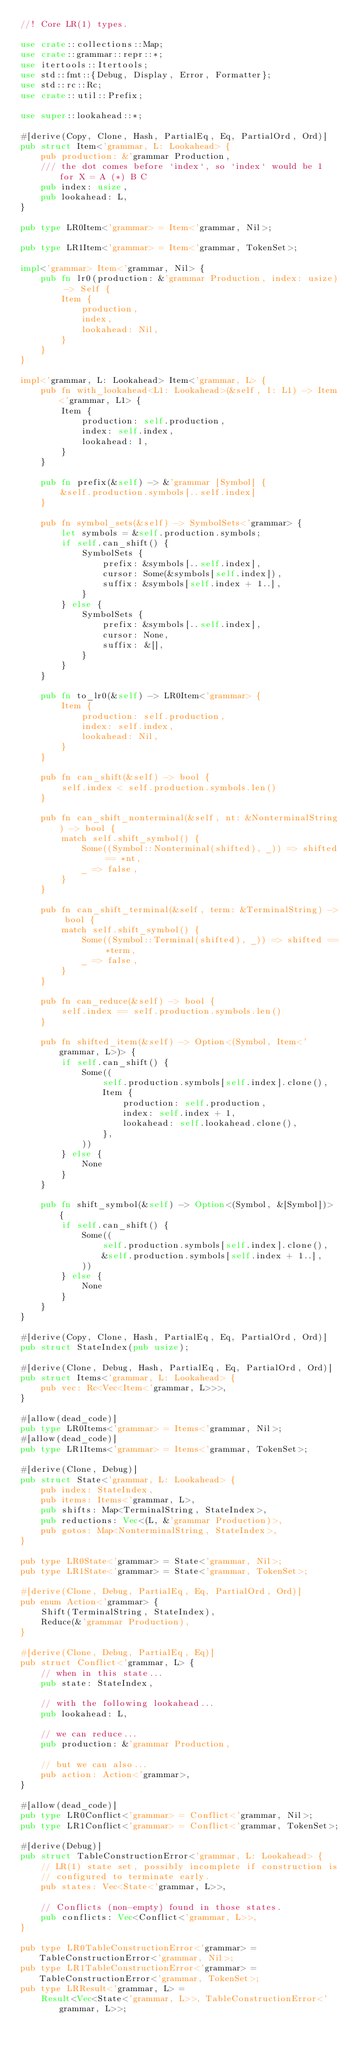<code> <loc_0><loc_0><loc_500><loc_500><_Rust_>//! Core LR(1) types.

use crate::collections::Map;
use crate::grammar::repr::*;
use itertools::Itertools;
use std::fmt::{Debug, Display, Error, Formatter};
use std::rc::Rc;
use crate::util::Prefix;

use super::lookahead::*;

#[derive(Copy, Clone, Hash, PartialEq, Eq, PartialOrd, Ord)]
pub struct Item<'grammar, L: Lookahead> {
    pub production: &'grammar Production,
    /// the dot comes before `index`, so `index` would be 1 for X = A (*) B C
    pub index: usize,
    pub lookahead: L,
}

pub type LR0Item<'grammar> = Item<'grammar, Nil>;

pub type LR1Item<'grammar> = Item<'grammar, TokenSet>;

impl<'grammar> Item<'grammar, Nil> {
    pub fn lr0(production: &'grammar Production, index: usize) -> Self {
        Item {
            production,
            index,
            lookahead: Nil,
        }
    }
}

impl<'grammar, L: Lookahead> Item<'grammar, L> {
    pub fn with_lookahead<L1: Lookahead>(&self, l: L1) -> Item<'grammar, L1> {
        Item {
            production: self.production,
            index: self.index,
            lookahead: l,
        }
    }

    pub fn prefix(&self) -> &'grammar [Symbol] {
        &self.production.symbols[..self.index]
    }

    pub fn symbol_sets(&self) -> SymbolSets<'grammar> {
        let symbols = &self.production.symbols;
        if self.can_shift() {
            SymbolSets {
                prefix: &symbols[..self.index],
                cursor: Some(&symbols[self.index]),
                suffix: &symbols[self.index + 1..],
            }
        } else {
            SymbolSets {
                prefix: &symbols[..self.index],
                cursor: None,
                suffix: &[],
            }
        }
    }

    pub fn to_lr0(&self) -> LR0Item<'grammar> {
        Item {
            production: self.production,
            index: self.index,
            lookahead: Nil,
        }
    }

    pub fn can_shift(&self) -> bool {
        self.index < self.production.symbols.len()
    }

    pub fn can_shift_nonterminal(&self, nt: &NonterminalString) -> bool {
        match self.shift_symbol() {
            Some((Symbol::Nonterminal(shifted), _)) => shifted == *nt,
            _ => false,
        }
    }

    pub fn can_shift_terminal(&self, term: &TerminalString) -> bool {
        match self.shift_symbol() {
            Some((Symbol::Terminal(shifted), _)) => shifted == *term,
            _ => false,
        }
    }

    pub fn can_reduce(&self) -> bool {
        self.index == self.production.symbols.len()
    }

    pub fn shifted_item(&self) -> Option<(Symbol, Item<'grammar, L>)> {
        if self.can_shift() {
            Some((
                self.production.symbols[self.index].clone(),
                Item {
                    production: self.production,
                    index: self.index + 1,
                    lookahead: self.lookahead.clone(),
                },
            ))
        } else {
            None
        }
    }

    pub fn shift_symbol(&self) -> Option<(Symbol, &[Symbol])> {
        if self.can_shift() {
            Some((
                self.production.symbols[self.index].clone(),
                &self.production.symbols[self.index + 1..],
            ))
        } else {
            None
        }
    }
}

#[derive(Copy, Clone, Hash, PartialEq, Eq, PartialOrd, Ord)]
pub struct StateIndex(pub usize);

#[derive(Clone, Debug, Hash, PartialEq, Eq, PartialOrd, Ord)]
pub struct Items<'grammar, L: Lookahead> {
    pub vec: Rc<Vec<Item<'grammar, L>>>,
}

#[allow(dead_code)]
pub type LR0Items<'grammar> = Items<'grammar, Nil>;
#[allow(dead_code)]
pub type LR1Items<'grammar> = Items<'grammar, TokenSet>;

#[derive(Clone, Debug)]
pub struct State<'grammar, L: Lookahead> {
    pub index: StateIndex,
    pub items: Items<'grammar, L>,
    pub shifts: Map<TerminalString, StateIndex>,
    pub reductions: Vec<(L, &'grammar Production)>,
    pub gotos: Map<NonterminalString, StateIndex>,
}

pub type LR0State<'grammar> = State<'grammar, Nil>;
pub type LR1State<'grammar> = State<'grammar, TokenSet>;

#[derive(Clone, Debug, PartialEq, Eq, PartialOrd, Ord)]
pub enum Action<'grammar> {
    Shift(TerminalString, StateIndex),
    Reduce(&'grammar Production),
}

#[derive(Clone, Debug, PartialEq, Eq)]
pub struct Conflict<'grammar, L> {
    // when in this state...
    pub state: StateIndex,

    // with the following lookahead...
    pub lookahead: L,

    // we can reduce...
    pub production: &'grammar Production,

    // but we can also...
    pub action: Action<'grammar>,
}

#[allow(dead_code)]
pub type LR0Conflict<'grammar> = Conflict<'grammar, Nil>;
pub type LR1Conflict<'grammar> = Conflict<'grammar, TokenSet>;

#[derive(Debug)]
pub struct TableConstructionError<'grammar, L: Lookahead> {
    // LR(1) state set, possibly incomplete if construction is
    // configured to terminate early.
    pub states: Vec<State<'grammar, L>>,

    // Conflicts (non-empty) found in those states.
    pub conflicts: Vec<Conflict<'grammar, L>>,
}

pub type LR0TableConstructionError<'grammar> = TableConstructionError<'grammar, Nil>;
pub type LR1TableConstructionError<'grammar> = TableConstructionError<'grammar, TokenSet>;
pub type LRResult<'grammar, L> =
    Result<Vec<State<'grammar, L>>, TableConstructionError<'grammar, L>>;</code> 